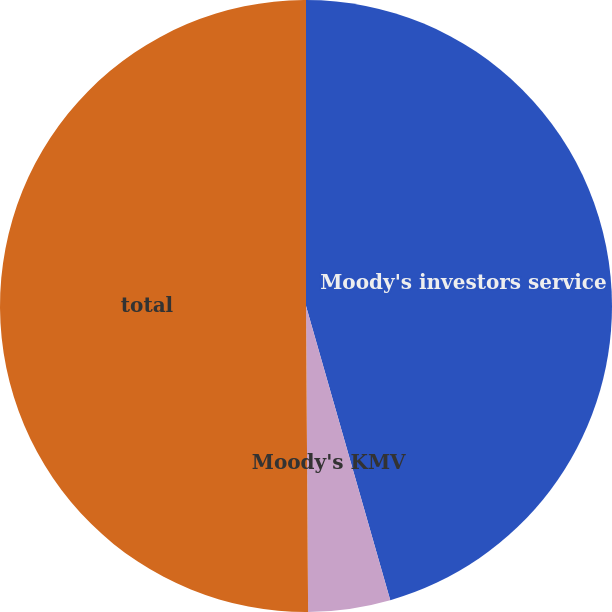<chart> <loc_0><loc_0><loc_500><loc_500><pie_chart><fcel>Moody's investors service<fcel>Moody's KMV<fcel>total<nl><fcel>45.56%<fcel>4.33%<fcel>50.11%<nl></chart> 